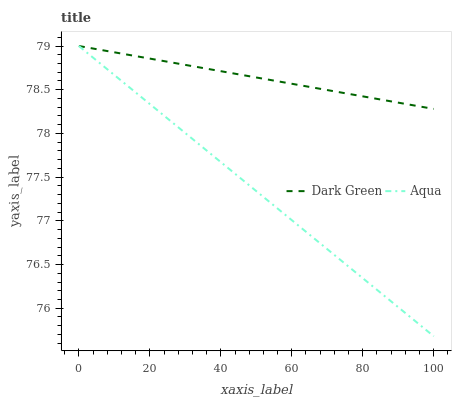Does Aqua have the minimum area under the curve?
Answer yes or no. Yes. Does Dark Green have the maximum area under the curve?
Answer yes or no. Yes. Does Dark Green have the minimum area under the curve?
Answer yes or no. No. Is Aqua the smoothest?
Answer yes or no. Yes. Is Dark Green the roughest?
Answer yes or no. Yes. Is Dark Green the smoothest?
Answer yes or no. No. Does Aqua have the lowest value?
Answer yes or no. Yes. Does Dark Green have the lowest value?
Answer yes or no. No. Does Dark Green have the highest value?
Answer yes or no. Yes. Does Dark Green intersect Aqua?
Answer yes or no. Yes. Is Dark Green less than Aqua?
Answer yes or no. No. Is Dark Green greater than Aqua?
Answer yes or no. No. 